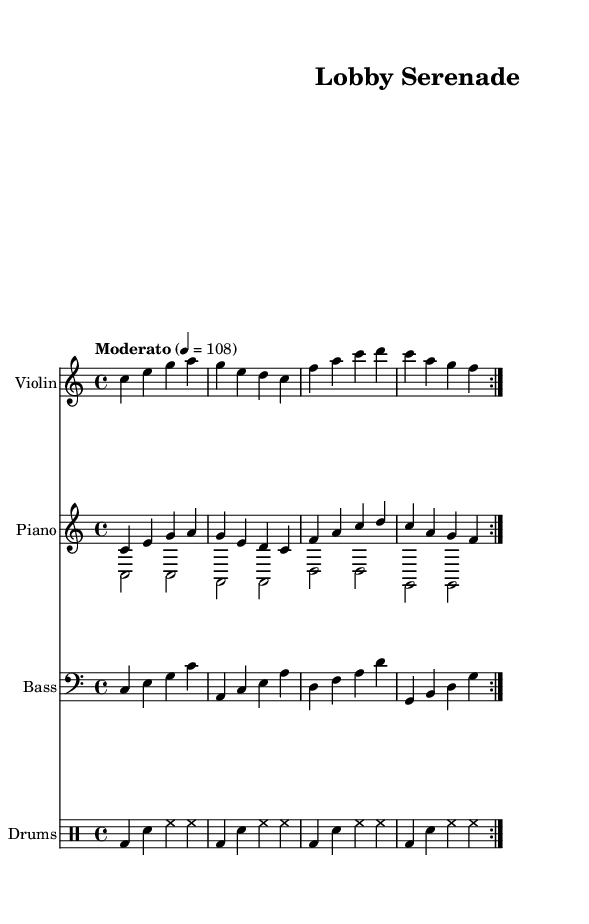What is the key signature of this music? The key signature is identified by looking at the beginning of the sheet music where the clefs and key signature are notated. It is in C major, which shows no sharps or flats.
Answer: C major What is the time signature of this piece? The time signature is determined by observing the numbers at the beginning of the music. It is indicated as 4/4, meaning there are four beats in a measure and a quarter note gets one beat.
Answer: 4/4 What is the tempo marking given in the score? The tempo marking is found below the title and indicates the speed of the music. In this case, it states "Moderato," with a metronome marking of 108 beats per minute, which refers to the speed of the quarter note.
Answer: Moderato How many times is the main theme repeated in this composition? The repeats are indicated by the "volta" notation in the music. The score shows "repeat volta 2" before the main theme, denoting that it is intended to be played twice.
Answer: 2 What instruments are featured in this sheet music? The instruments are listed at the beginning of each staff line in the sheet music. There are four instruments: Violin, Piano, Bass, and Drums.
Answer: Violin, Piano, Bass, Drums What characteristic makes this piece a fusion of jazz and classical? The piece combines elements of jazz, such as swing rhythm and improvisation potential, with classical structural music forms, like the melodic lines and written parts, creating a cross-genre blend.
Answer: Swing rhythm, melodic lines 